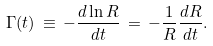Convert formula to latex. <formula><loc_0><loc_0><loc_500><loc_500>\Gamma ( t ) \, \equiv \, - \frac { d \ln R } { d t } \, = \, - \frac { 1 } { R } \frac { d R } { d t } .</formula> 